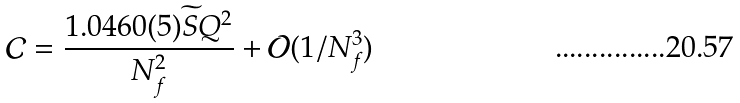<formula> <loc_0><loc_0><loc_500><loc_500>\mathcal { C } = \frac { 1 . 0 4 6 0 ( 5 ) \widetilde { S } Q ^ { 2 } } { N _ { f } ^ { 2 } } + \mathcal { O } ( 1 / N _ { f } ^ { 3 } )</formula> 